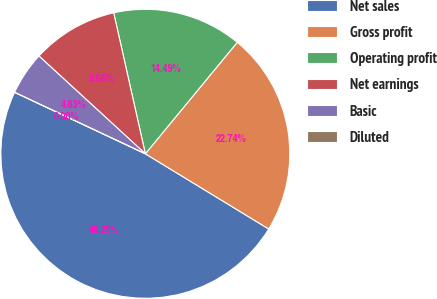<chart> <loc_0><loc_0><loc_500><loc_500><pie_chart><fcel>Net sales<fcel>Gross profit<fcel>Operating profit<fcel>Net earnings<fcel>Basic<fcel>Diluted<nl><fcel>48.29%<fcel>22.74%<fcel>14.49%<fcel>9.66%<fcel>4.83%<fcel>0.0%<nl></chart> 